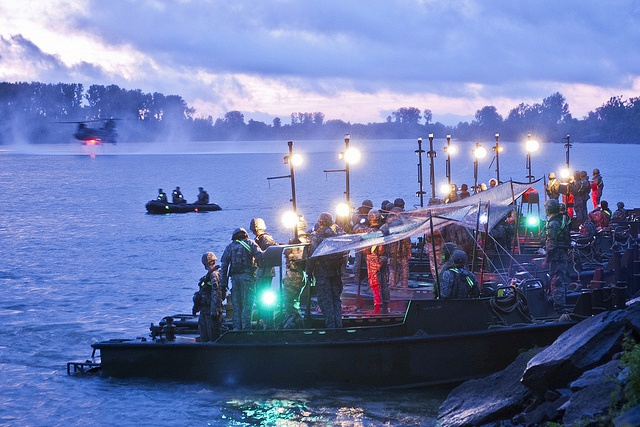Describe the objects in this image and their specific colors. I can see boat in white, black, navy, darkblue, and blue tones, people in white, navy, black, darkgray, and purple tones, people in white, blue, navy, and black tones, people in white, black, gray, and darkgray tones, and people in white, black, navy, gray, and darkblue tones in this image. 